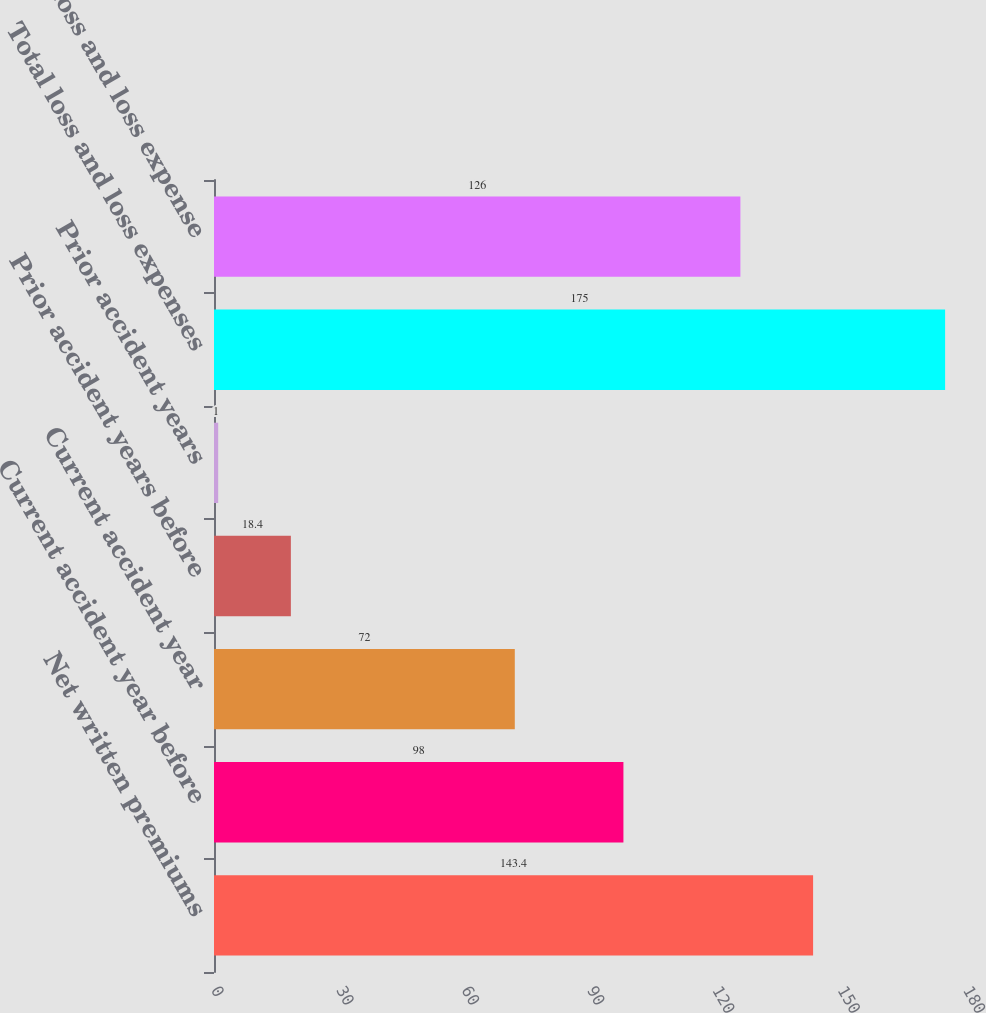Convert chart. <chart><loc_0><loc_0><loc_500><loc_500><bar_chart><fcel>Net written premiums<fcel>Current accident year before<fcel>Current accident year<fcel>Prior accident years before<fcel>Prior accident years<fcel>Total loss and loss expenses<fcel>Total loss and loss expense<nl><fcel>143.4<fcel>98<fcel>72<fcel>18.4<fcel>1<fcel>175<fcel>126<nl></chart> 